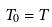Convert formula to latex. <formula><loc_0><loc_0><loc_500><loc_500>T _ { 0 } = T</formula> 